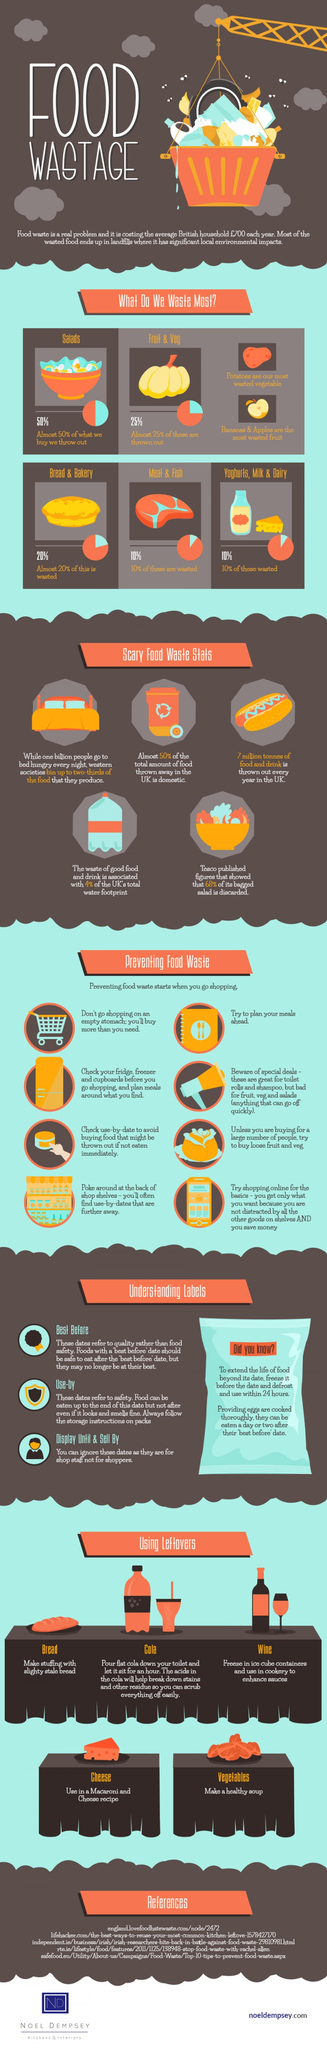List a handful of essential elements in this visual. Ninety percent of yogurts, milk, and dairy products were not wasted. The labels on food products include "Best before," "Use-by," "Display until," and "Sell By" which provide information on the quality and safety of the food. Approximately 80% of bread and bakery products are not wasted. In this infographic, eight ways are presented to prevent food waste, making it an informative and helpful resource for individuals looking to reduce their food waste. 